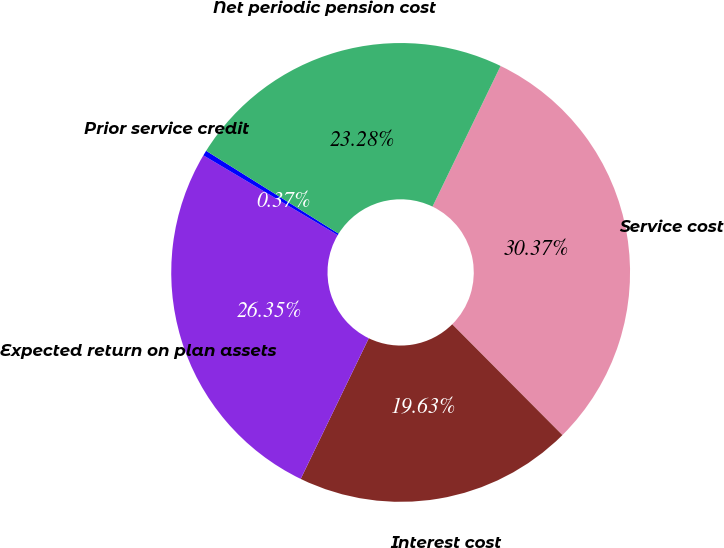Convert chart to OTSL. <chart><loc_0><loc_0><loc_500><loc_500><pie_chart><fcel>Service cost<fcel>Interest cost<fcel>Expected return on plan assets<fcel>Prior service credit<fcel>Net periodic pension cost<nl><fcel>30.37%<fcel>19.63%<fcel>26.35%<fcel>0.37%<fcel>23.28%<nl></chart> 